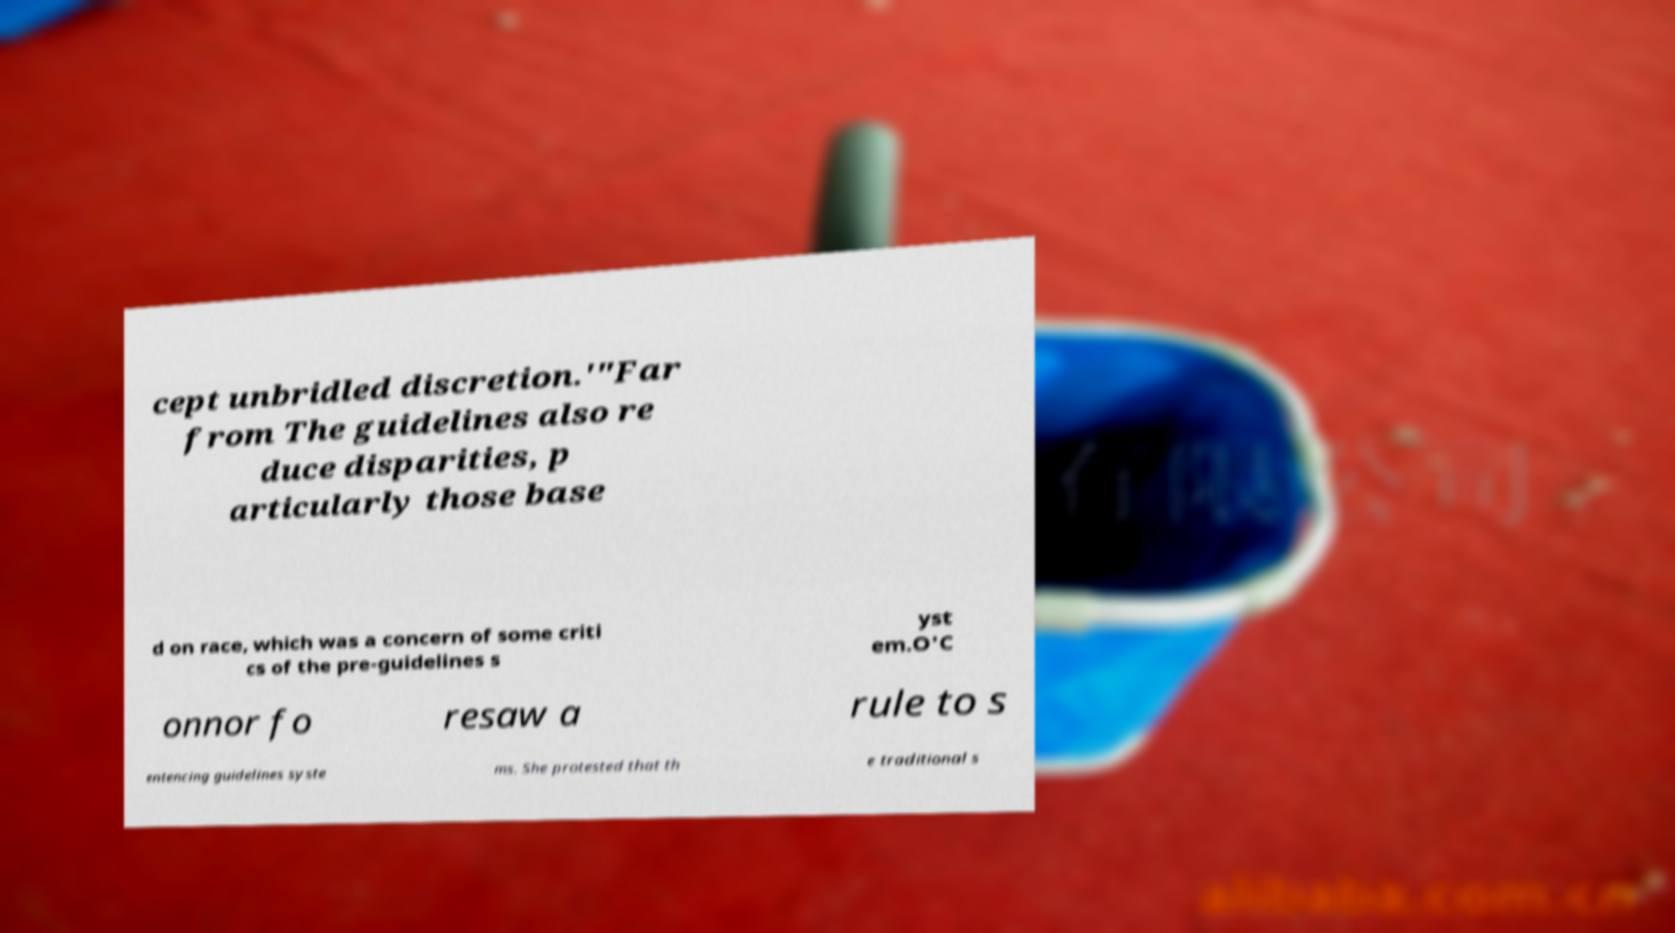Can you accurately transcribe the text from the provided image for me? cept unbridled discretion.'"Far from The guidelines also re duce disparities, p articularly those base d on race, which was a concern of some criti cs of the pre-guidelines s yst em.O'C onnor fo resaw a rule to s entencing guidelines syste ms. She protested that th e traditional s 